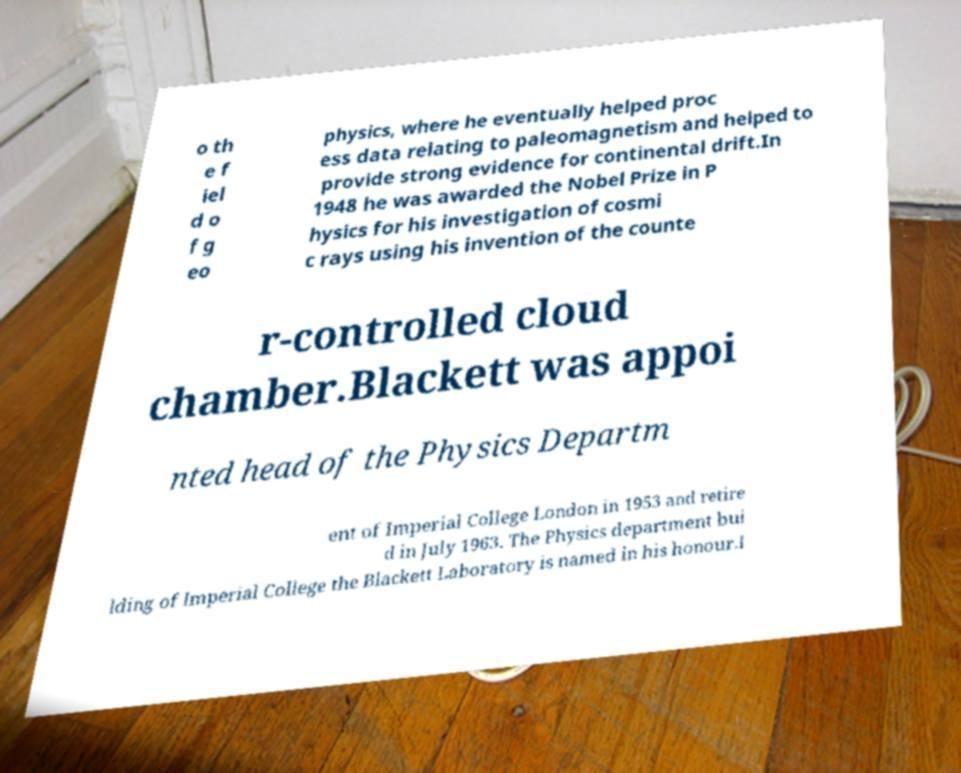Can you accurately transcribe the text from the provided image for me? o th e f iel d o f g eo physics, where he eventually helped proc ess data relating to paleomagnetism and helped to provide strong evidence for continental drift.In 1948 he was awarded the Nobel Prize in P hysics for his investigation of cosmi c rays using his invention of the counte r-controlled cloud chamber.Blackett was appoi nted head of the Physics Departm ent of Imperial College London in 1953 and retire d in July 1963. The Physics department bui lding of Imperial College the Blackett Laboratory is named in his honour.I 